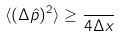<formula> <loc_0><loc_0><loc_500><loc_500>\langle ( \Delta \hat { p } ) ^ { 2 } \rangle \geq \frac { } { 4 \Delta x }</formula> 